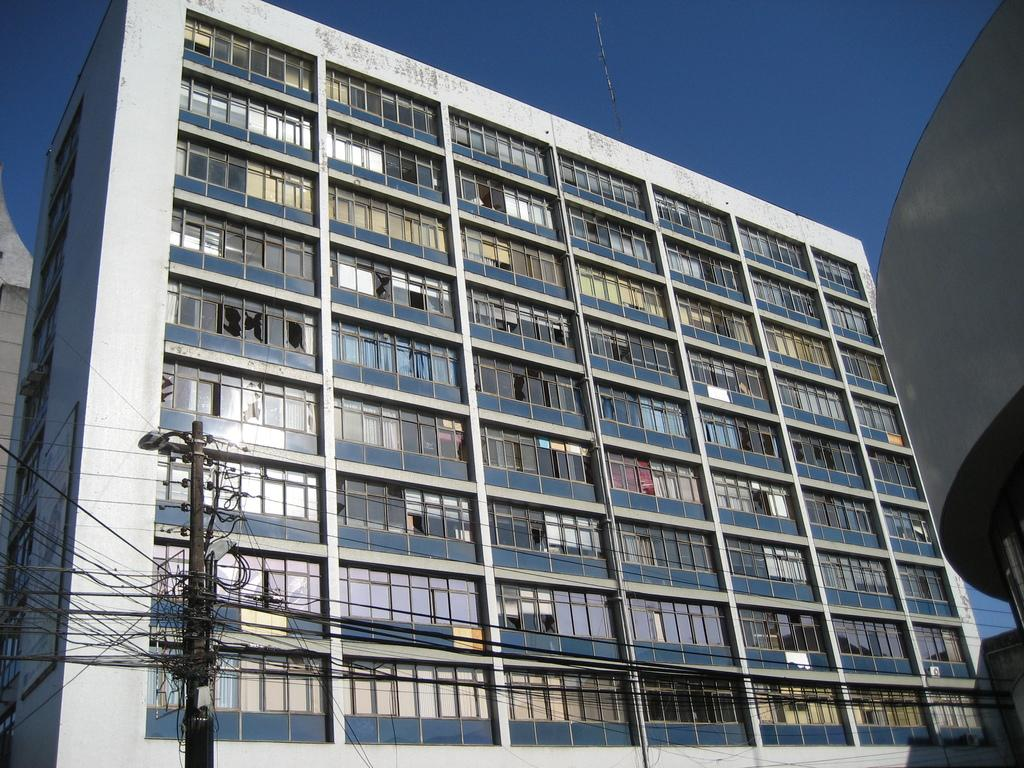What type of structure is present in the image? There is a building in the image. What else can be seen in the image besides the building? There is a pole and wires in the image. What is visible in the background of the image? The sky is visible in the background of the image. What type of engine can be seen powering the building in the image? There is no engine present in the image, and the building is not depicted as being powered by any visible engine. 